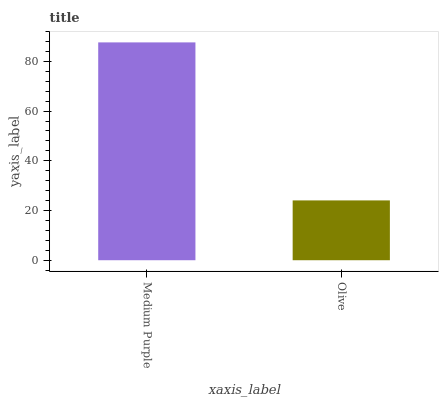Is Olive the minimum?
Answer yes or no. Yes. Is Medium Purple the maximum?
Answer yes or no. Yes. Is Olive the maximum?
Answer yes or no. No. Is Medium Purple greater than Olive?
Answer yes or no. Yes. Is Olive less than Medium Purple?
Answer yes or no. Yes. Is Olive greater than Medium Purple?
Answer yes or no. No. Is Medium Purple less than Olive?
Answer yes or no. No. Is Medium Purple the high median?
Answer yes or no. Yes. Is Olive the low median?
Answer yes or no. Yes. Is Olive the high median?
Answer yes or no. No. Is Medium Purple the low median?
Answer yes or no. No. 